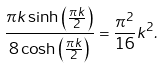<formula> <loc_0><loc_0><loc_500><loc_500>\frac { \pi k \sinh \left ( \frac { \pi k } { 2 } \right ) } { 8 \cosh \left ( \frac { \pi k } { 2 } \right ) } = \frac { \pi ^ { 2 } } { 1 6 } k ^ { 2 } .</formula> 